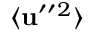<formula> <loc_0><loc_0><loc_500><loc_500>\langle { { u } ^ { \prime \prime ^ { 2 } } \rangle</formula> 